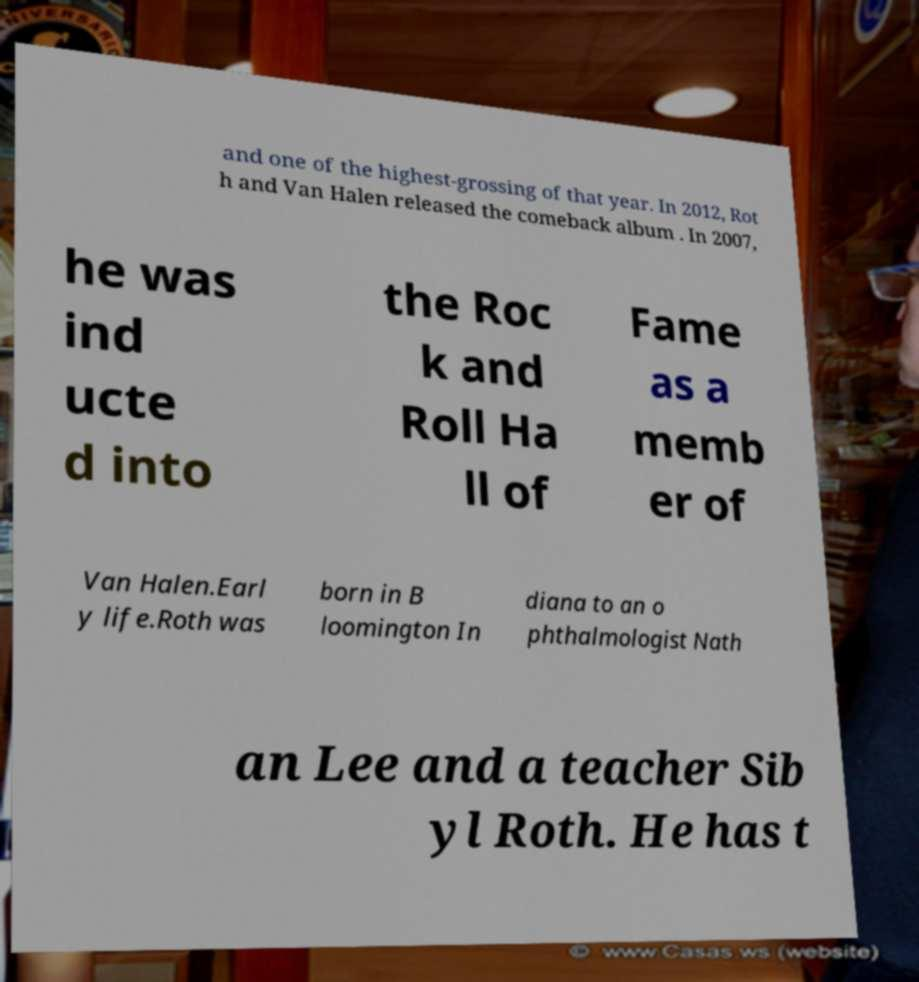I need the written content from this picture converted into text. Can you do that? and one of the highest-grossing of that year. In 2012, Rot h and Van Halen released the comeback album . In 2007, he was ind ucte d into the Roc k and Roll Ha ll of Fame as a memb er of Van Halen.Earl y life.Roth was born in B loomington In diana to an o phthalmologist Nath an Lee and a teacher Sib yl Roth. He has t 